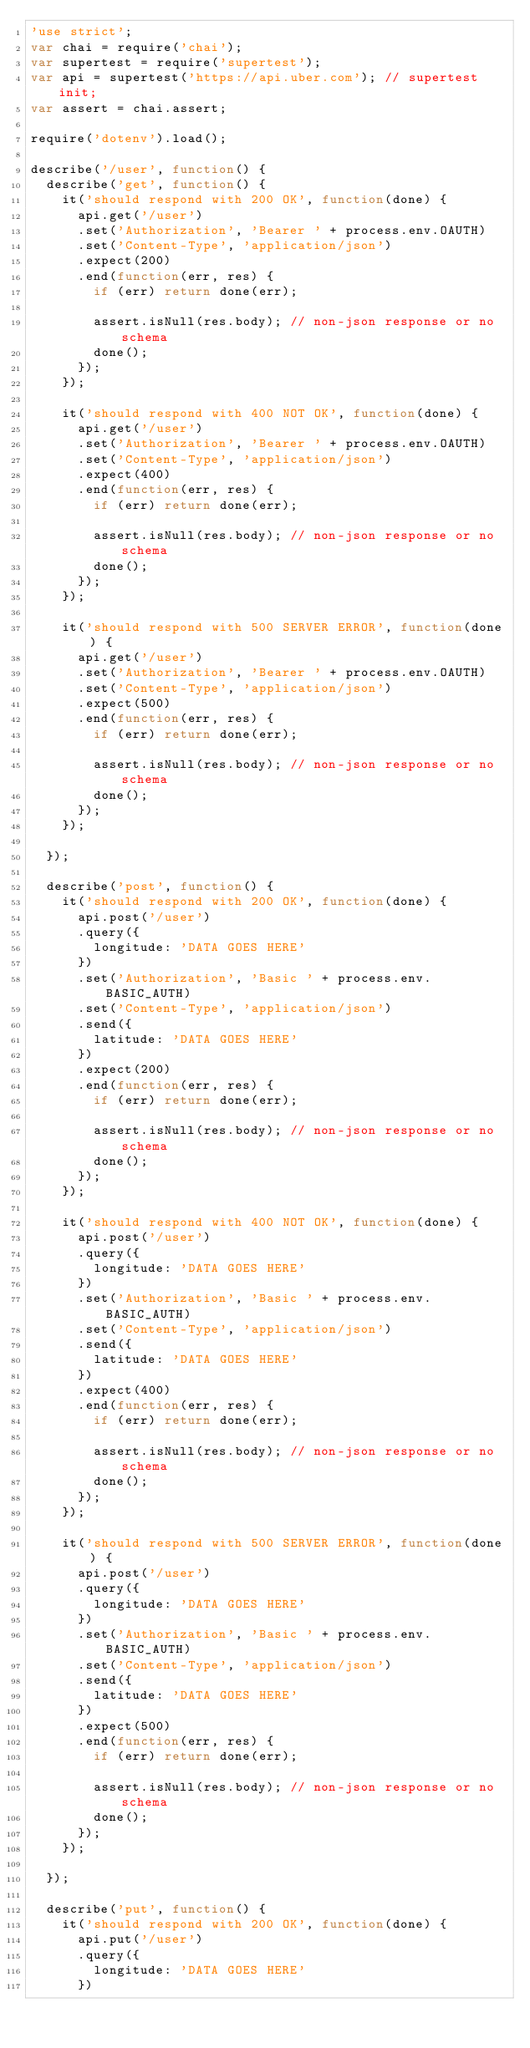Convert code to text. <code><loc_0><loc_0><loc_500><loc_500><_JavaScript_>'use strict';
var chai = require('chai');
var supertest = require('supertest');
var api = supertest('https://api.uber.com'); // supertest init;
var assert = chai.assert;

require('dotenv').load();

describe('/user', function() {
  describe('get', function() {
    it('should respond with 200 OK', function(done) {
      api.get('/user')
      .set('Authorization', 'Bearer ' + process.env.OAUTH)
      .set('Content-Type', 'application/json')
      .expect(200)
      .end(function(err, res) {
        if (err) return done(err);

        assert.isNull(res.body); // non-json response or no schema
        done();
      });
    });

    it('should respond with 400 NOT OK', function(done) {
      api.get('/user')
      .set('Authorization', 'Bearer ' + process.env.OAUTH)
      .set('Content-Type', 'application/json')
      .expect(400)
      .end(function(err, res) {
        if (err) return done(err);

        assert.isNull(res.body); // non-json response or no schema
        done();
      });
    });

    it('should respond with 500 SERVER ERROR', function(done) {
      api.get('/user')
      .set('Authorization', 'Bearer ' + process.env.OAUTH)
      .set('Content-Type', 'application/json')
      .expect(500)
      .end(function(err, res) {
        if (err) return done(err);

        assert.isNull(res.body); // non-json response or no schema
        done();
      });
    });

  });

  describe('post', function() {
    it('should respond with 200 OK', function(done) {
      api.post('/user')
      .query({
        longitude: 'DATA GOES HERE'
      })
      .set('Authorization', 'Basic ' + process.env.BASIC_AUTH)
      .set('Content-Type', 'application/json')
      .send({
        latitude: 'DATA GOES HERE'
      })
      .expect(200)
      .end(function(err, res) {
        if (err) return done(err);

        assert.isNull(res.body); // non-json response or no schema
        done();
      });
    });

    it('should respond with 400 NOT OK', function(done) {
      api.post('/user')
      .query({
        longitude: 'DATA GOES HERE'
      })
      .set('Authorization', 'Basic ' + process.env.BASIC_AUTH)
      .set('Content-Type', 'application/json')
      .send({
        latitude: 'DATA GOES HERE'
      })
      .expect(400)
      .end(function(err, res) {
        if (err) return done(err);

        assert.isNull(res.body); // non-json response or no schema
        done();
      });
    });

    it('should respond with 500 SERVER ERROR', function(done) {
      api.post('/user')
      .query({
        longitude: 'DATA GOES HERE'
      })
      .set('Authorization', 'Basic ' + process.env.BASIC_AUTH)
      .set('Content-Type', 'application/json')
      .send({
        latitude: 'DATA GOES HERE'
      })
      .expect(500)
      .end(function(err, res) {
        if (err) return done(err);

        assert.isNull(res.body); // non-json response or no schema
        done();
      });
    });

  });

  describe('put', function() {
    it('should respond with 200 OK', function(done) {
      api.put('/user')
      .query({
        longitude: 'DATA GOES HERE'
      })</code> 